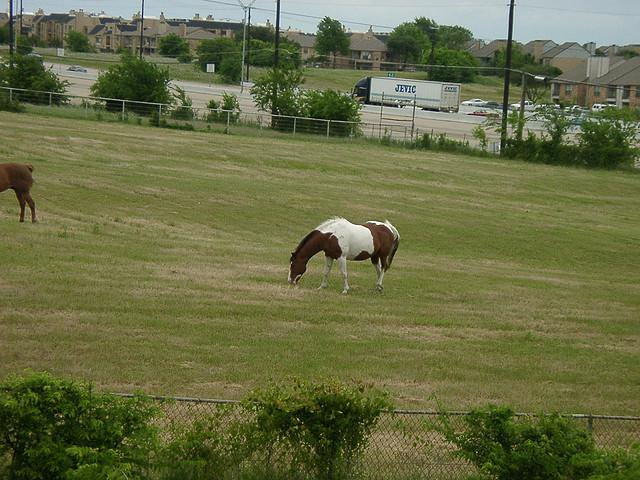What type of animals are present? horses 